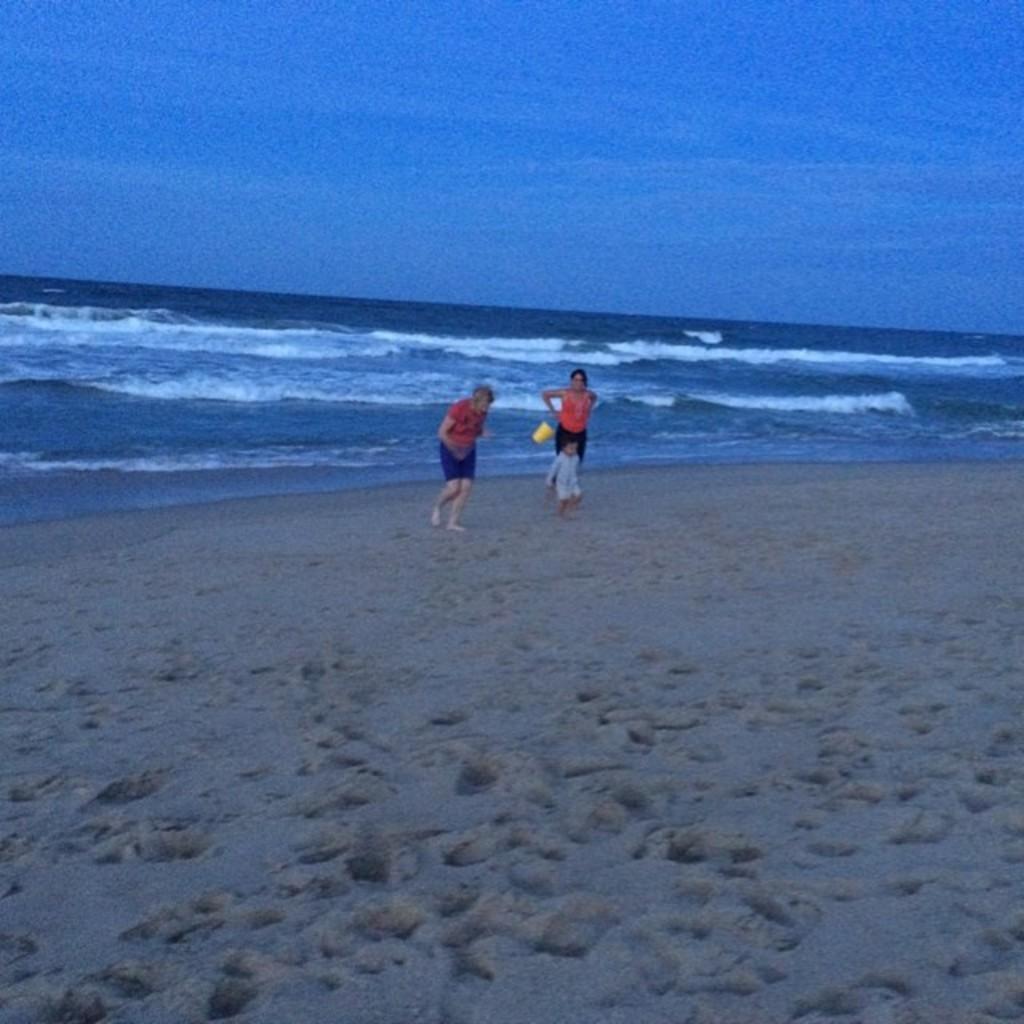Could you give a brief overview of what you see in this image? In this picture there are two persons running and there is a person holding the object and standing. At the back there is water. At the top there is sky and there are clouds. At the bottom there is sand. 